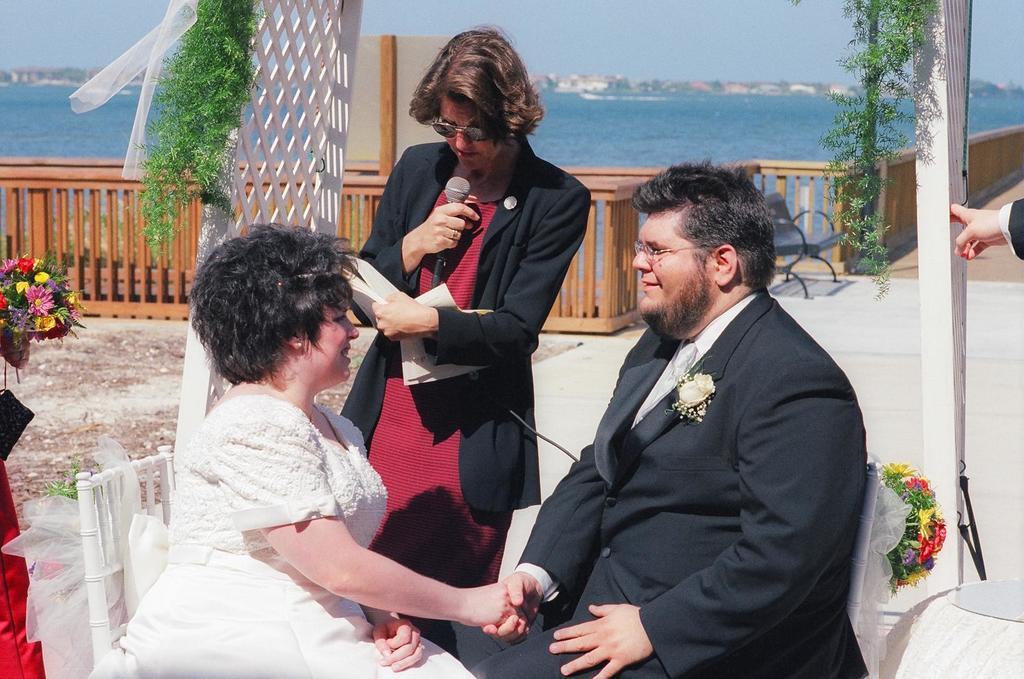Can you describe this image briefly? At the bottom of the image two persons are sitting and holding hands and smiling. Beside them a person is standing and holding a paper and microphone. Behind him there is fencing. Behind the fencing we can see water and trees and buildings. At the top of the image there is sky. 